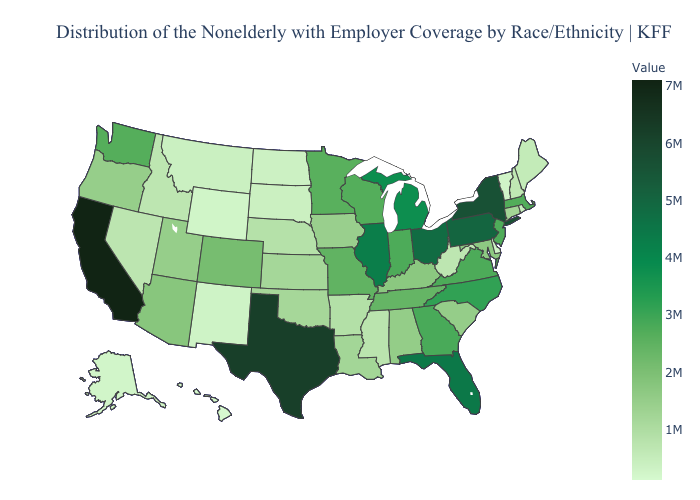Does Idaho have the lowest value in the USA?
Keep it brief. No. Does California have the highest value in the USA?
Answer briefly. Yes. Among the states that border Oregon , does Nevada have the lowest value?
Short answer required. No. Which states hav the highest value in the Northeast?
Keep it brief. New York. 